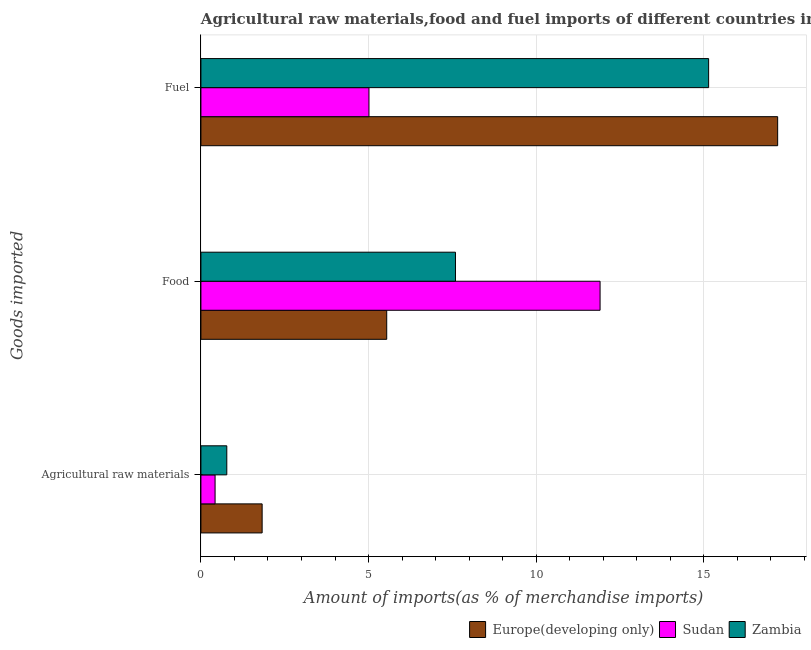Are the number of bars on each tick of the Y-axis equal?
Your answer should be compact. Yes. What is the label of the 3rd group of bars from the top?
Your response must be concise. Agricultural raw materials. What is the percentage of food imports in Zambia?
Offer a terse response. 7.59. Across all countries, what is the maximum percentage of raw materials imports?
Your answer should be compact. 1.83. Across all countries, what is the minimum percentage of food imports?
Keep it short and to the point. 5.54. In which country was the percentage of fuel imports maximum?
Provide a succinct answer. Europe(developing only). In which country was the percentage of raw materials imports minimum?
Keep it short and to the point. Sudan. What is the total percentage of raw materials imports in the graph?
Your answer should be compact. 3.02. What is the difference between the percentage of raw materials imports in Zambia and that in Europe(developing only)?
Ensure brevity in your answer.  -1.05. What is the difference between the percentage of food imports in Zambia and the percentage of fuel imports in Sudan?
Ensure brevity in your answer.  2.58. What is the average percentage of fuel imports per country?
Provide a succinct answer. 12.45. What is the difference between the percentage of fuel imports and percentage of raw materials imports in Zambia?
Your response must be concise. 14.37. What is the ratio of the percentage of raw materials imports in Sudan to that in Europe(developing only)?
Offer a terse response. 0.23. Is the percentage of fuel imports in Europe(developing only) less than that in Sudan?
Offer a terse response. No. What is the difference between the highest and the second highest percentage of fuel imports?
Your answer should be very brief. 2.06. What is the difference between the highest and the lowest percentage of fuel imports?
Give a very brief answer. 12.19. In how many countries, is the percentage of food imports greater than the average percentage of food imports taken over all countries?
Provide a short and direct response. 1. Is the sum of the percentage of raw materials imports in Zambia and Sudan greater than the maximum percentage of food imports across all countries?
Provide a succinct answer. No. What does the 1st bar from the top in Agricultural raw materials represents?
Your answer should be very brief. Zambia. What does the 2nd bar from the bottom in Fuel represents?
Provide a succinct answer. Sudan. How many bars are there?
Your answer should be very brief. 9. What is the difference between two consecutive major ticks on the X-axis?
Keep it short and to the point. 5. Does the graph contain grids?
Keep it short and to the point. Yes. Where does the legend appear in the graph?
Offer a terse response. Bottom right. What is the title of the graph?
Make the answer very short. Agricultural raw materials,food and fuel imports of different countries in 2006. Does "Bhutan" appear as one of the legend labels in the graph?
Offer a terse response. No. What is the label or title of the X-axis?
Your response must be concise. Amount of imports(as % of merchandise imports). What is the label or title of the Y-axis?
Provide a succinct answer. Goods imported. What is the Amount of imports(as % of merchandise imports) of Europe(developing only) in Agricultural raw materials?
Provide a succinct answer. 1.83. What is the Amount of imports(as % of merchandise imports) of Sudan in Agricultural raw materials?
Your answer should be very brief. 0.42. What is the Amount of imports(as % of merchandise imports) in Zambia in Agricultural raw materials?
Your answer should be very brief. 0.77. What is the Amount of imports(as % of merchandise imports) of Europe(developing only) in Food?
Offer a terse response. 5.54. What is the Amount of imports(as % of merchandise imports) of Sudan in Food?
Your response must be concise. 11.9. What is the Amount of imports(as % of merchandise imports) of Zambia in Food?
Provide a succinct answer. 7.59. What is the Amount of imports(as % of merchandise imports) of Europe(developing only) in Fuel?
Keep it short and to the point. 17.2. What is the Amount of imports(as % of merchandise imports) of Sudan in Fuel?
Your response must be concise. 5.01. What is the Amount of imports(as % of merchandise imports) of Zambia in Fuel?
Offer a terse response. 15.14. Across all Goods imported, what is the maximum Amount of imports(as % of merchandise imports) of Europe(developing only)?
Your response must be concise. 17.2. Across all Goods imported, what is the maximum Amount of imports(as % of merchandise imports) in Sudan?
Give a very brief answer. 11.9. Across all Goods imported, what is the maximum Amount of imports(as % of merchandise imports) in Zambia?
Make the answer very short. 15.14. Across all Goods imported, what is the minimum Amount of imports(as % of merchandise imports) in Europe(developing only)?
Provide a short and direct response. 1.83. Across all Goods imported, what is the minimum Amount of imports(as % of merchandise imports) of Sudan?
Give a very brief answer. 0.42. Across all Goods imported, what is the minimum Amount of imports(as % of merchandise imports) of Zambia?
Offer a very short reply. 0.77. What is the total Amount of imports(as % of merchandise imports) in Europe(developing only) in the graph?
Provide a succinct answer. 24.57. What is the total Amount of imports(as % of merchandise imports) of Sudan in the graph?
Your response must be concise. 17.34. What is the total Amount of imports(as % of merchandise imports) in Zambia in the graph?
Ensure brevity in your answer.  23.51. What is the difference between the Amount of imports(as % of merchandise imports) in Europe(developing only) in Agricultural raw materials and that in Food?
Your answer should be compact. -3.72. What is the difference between the Amount of imports(as % of merchandise imports) of Sudan in Agricultural raw materials and that in Food?
Your answer should be compact. -11.48. What is the difference between the Amount of imports(as % of merchandise imports) of Zambia in Agricultural raw materials and that in Food?
Offer a terse response. -6.82. What is the difference between the Amount of imports(as % of merchandise imports) in Europe(developing only) in Agricultural raw materials and that in Fuel?
Your response must be concise. -15.37. What is the difference between the Amount of imports(as % of merchandise imports) in Sudan in Agricultural raw materials and that in Fuel?
Give a very brief answer. -4.59. What is the difference between the Amount of imports(as % of merchandise imports) in Zambia in Agricultural raw materials and that in Fuel?
Provide a succinct answer. -14.37. What is the difference between the Amount of imports(as % of merchandise imports) of Europe(developing only) in Food and that in Fuel?
Provide a succinct answer. -11.66. What is the difference between the Amount of imports(as % of merchandise imports) in Sudan in Food and that in Fuel?
Keep it short and to the point. 6.89. What is the difference between the Amount of imports(as % of merchandise imports) in Zambia in Food and that in Fuel?
Make the answer very short. -7.55. What is the difference between the Amount of imports(as % of merchandise imports) of Europe(developing only) in Agricultural raw materials and the Amount of imports(as % of merchandise imports) of Sudan in Food?
Provide a succinct answer. -10.08. What is the difference between the Amount of imports(as % of merchandise imports) of Europe(developing only) in Agricultural raw materials and the Amount of imports(as % of merchandise imports) of Zambia in Food?
Your answer should be compact. -5.77. What is the difference between the Amount of imports(as % of merchandise imports) in Sudan in Agricultural raw materials and the Amount of imports(as % of merchandise imports) in Zambia in Food?
Offer a terse response. -7.17. What is the difference between the Amount of imports(as % of merchandise imports) of Europe(developing only) in Agricultural raw materials and the Amount of imports(as % of merchandise imports) of Sudan in Fuel?
Your response must be concise. -3.19. What is the difference between the Amount of imports(as % of merchandise imports) in Europe(developing only) in Agricultural raw materials and the Amount of imports(as % of merchandise imports) in Zambia in Fuel?
Offer a terse response. -13.32. What is the difference between the Amount of imports(as % of merchandise imports) in Sudan in Agricultural raw materials and the Amount of imports(as % of merchandise imports) in Zambia in Fuel?
Ensure brevity in your answer.  -14.72. What is the difference between the Amount of imports(as % of merchandise imports) in Europe(developing only) in Food and the Amount of imports(as % of merchandise imports) in Sudan in Fuel?
Provide a succinct answer. 0.53. What is the difference between the Amount of imports(as % of merchandise imports) in Europe(developing only) in Food and the Amount of imports(as % of merchandise imports) in Zambia in Fuel?
Give a very brief answer. -9.6. What is the difference between the Amount of imports(as % of merchandise imports) of Sudan in Food and the Amount of imports(as % of merchandise imports) of Zambia in Fuel?
Provide a succinct answer. -3.24. What is the average Amount of imports(as % of merchandise imports) of Europe(developing only) per Goods imported?
Make the answer very short. 8.19. What is the average Amount of imports(as % of merchandise imports) of Sudan per Goods imported?
Offer a terse response. 5.78. What is the average Amount of imports(as % of merchandise imports) of Zambia per Goods imported?
Ensure brevity in your answer.  7.84. What is the difference between the Amount of imports(as % of merchandise imports) in Europe(developing only) and Amount of imports(as % of merchandise imports) in Sudan in Agricultural raw materials?
Provide a short and direct response. 1.4. What is the difference between the Amount of imports(as % of merchandise imports) in Europe(developing only) and Amount of imports(as % of merchandise imports) in Zambia in Agricultural raw materials?
Your response must be concise. 1.05. What is the difference between the Amount of imports(as % of merchandise imports) in Sudan and Amount of imports(as % of merchandise imports) in Zambia in Agricultural raw materials?
Offer a very short reply. -0.35. What is the difference between the Amount of imports(as % of merchandise imports) in Europe(developing only) and Amount of imports(as % of merchandise imports) in Sudan in Food?
Offer a terse response. -6.36. What is the difference between the Amount of imports(as % of merchandise imports) of Europe(developing only) and Amount of imports(as % of merchandise imports) of Zambia in Food?
Offer a very short reply. -2.05. What is the difference between the Amount of imports(as % of merchandise imports) of Sudan and Amount of imports(as % of merchandise imports) of Zambia in Food?
Ensure brevity in your answer.  4.31. What is the difference between the Amount of imports(as % of merchandise imports) of Europe(developing only) and Amount of imports(as % of merchandise imports) of Sudan in Fuel?
Make the answer very short. 12.19. What is the difference between the Amount of imports(as % of merchandise imports) of Europe(developing only) and Amount of imports(as % of merchandise imports) of Zambia in Fuel?
Your answer should be very brief. 2.06. What is the difference between the Amount of imports(as % of merchandise imports) of Sudan and Amount of imports(as % of merchandise imports) of Zambia in Fuel?
Your answer should be very brief. -10.13. What is the ratio of the Amount of imports(as % of merchandise imports) of Europe(developing only) in Agricultural raw materials to that in Food?
Your answer should be compact. 0.33. What is the ratio of the Amount of imports(as % of merchandise imports) of Sudan in Agricultural raw materials to that in Food?
Ensure brevity in your answer.  0.04. What is the ratio of the Amount of imports(as % of merchandise imports) in Zambia in Agricultural raw materials to that in Food?
Make the answer very short. 0.1. What is the ratio of the Amount of imports(as % of merchandise imports) in Europe(developing only) in Agricultural raw materials to that in Fuel?
Your response must be concise. 0.11. What is the ratio of the Amount of imports(as % of merchandise imports) of Sudan in Agricultural raw materials to that in Fuel?
Offer a very short reply. 0.08. What is the ratio of the Amount of imports(as % of merchandise imports) in Zambia in Agricultural raw materials to that in Fuel?
Your response must be concise. 0.05. What is the ratio of the Amount of imports(as % of merchandise imports) of Europe(developing only) in Food to that in Fuel?
Make the answer very short. 0.32. What is the ratio of the Amount of imports(as % of merchandise imports) of Sudan in Food to that in Fuel?
Make the answer very short. 2.38. What is the ratio of the Amount of imports(as % of merchandise imports) of Zambia in Food to that in Fuel?
Provide a short and direct response. 0.5. What is the difference between the highest and the second highest Amount of imports(as % of merchandise imports) of Europe(developing only)?
Make the answer very short. 11.66. What is the difference between the highest and the second highest Amount of imports(as % of merchandise imports) in Sudan?
Keep it short and to the point. 6.89. What is the difference between the highest and the second highest Amount of imports(as % of merchandise imports) in Zambia?
Offer a terse response. 7.55. What is the difference between the highest and the lowest Amount of imports(as % of merchandise imports) in Europe(developing only)?
Offer a terse response. 15.37. What is the difference between the highest and the lowest Amount of imports(as % of merchandise imports) of Sudan?
Offer a very short reply. 11.48. What is the difference between the highest and the lowest Amount of imports(as % of merchandise imports) of Zambia?
Provide a succinct answer. 14.37. 